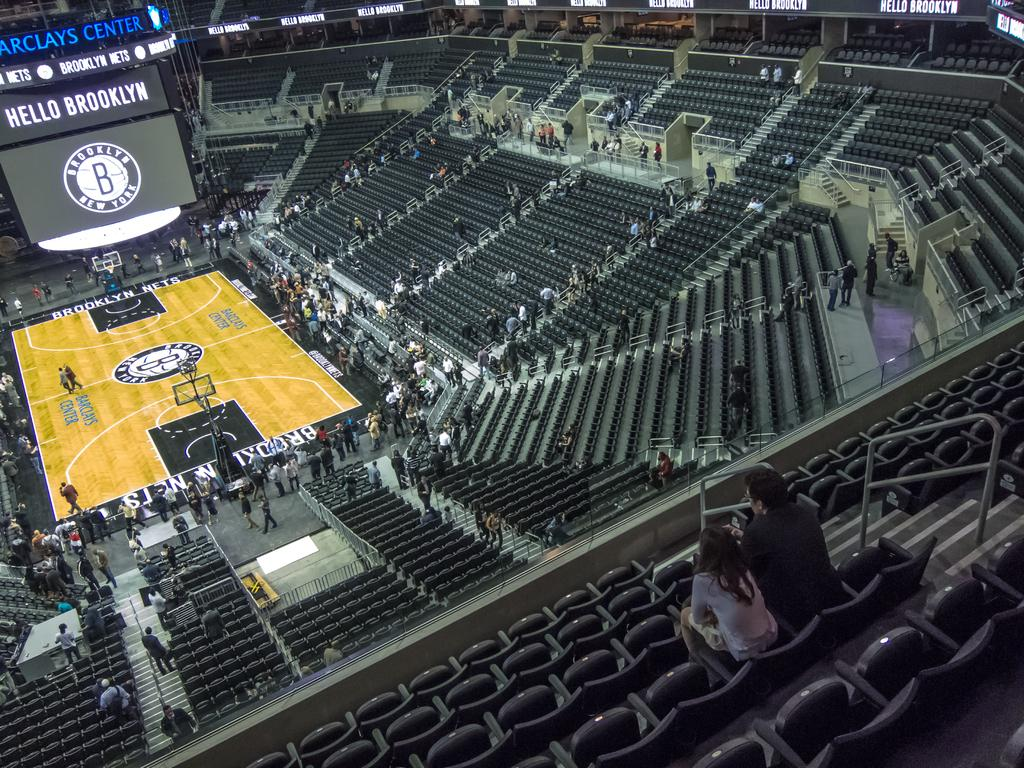Provide a one-sentence caption for the provided image. Fans fill in the Barclays Center before a game. 